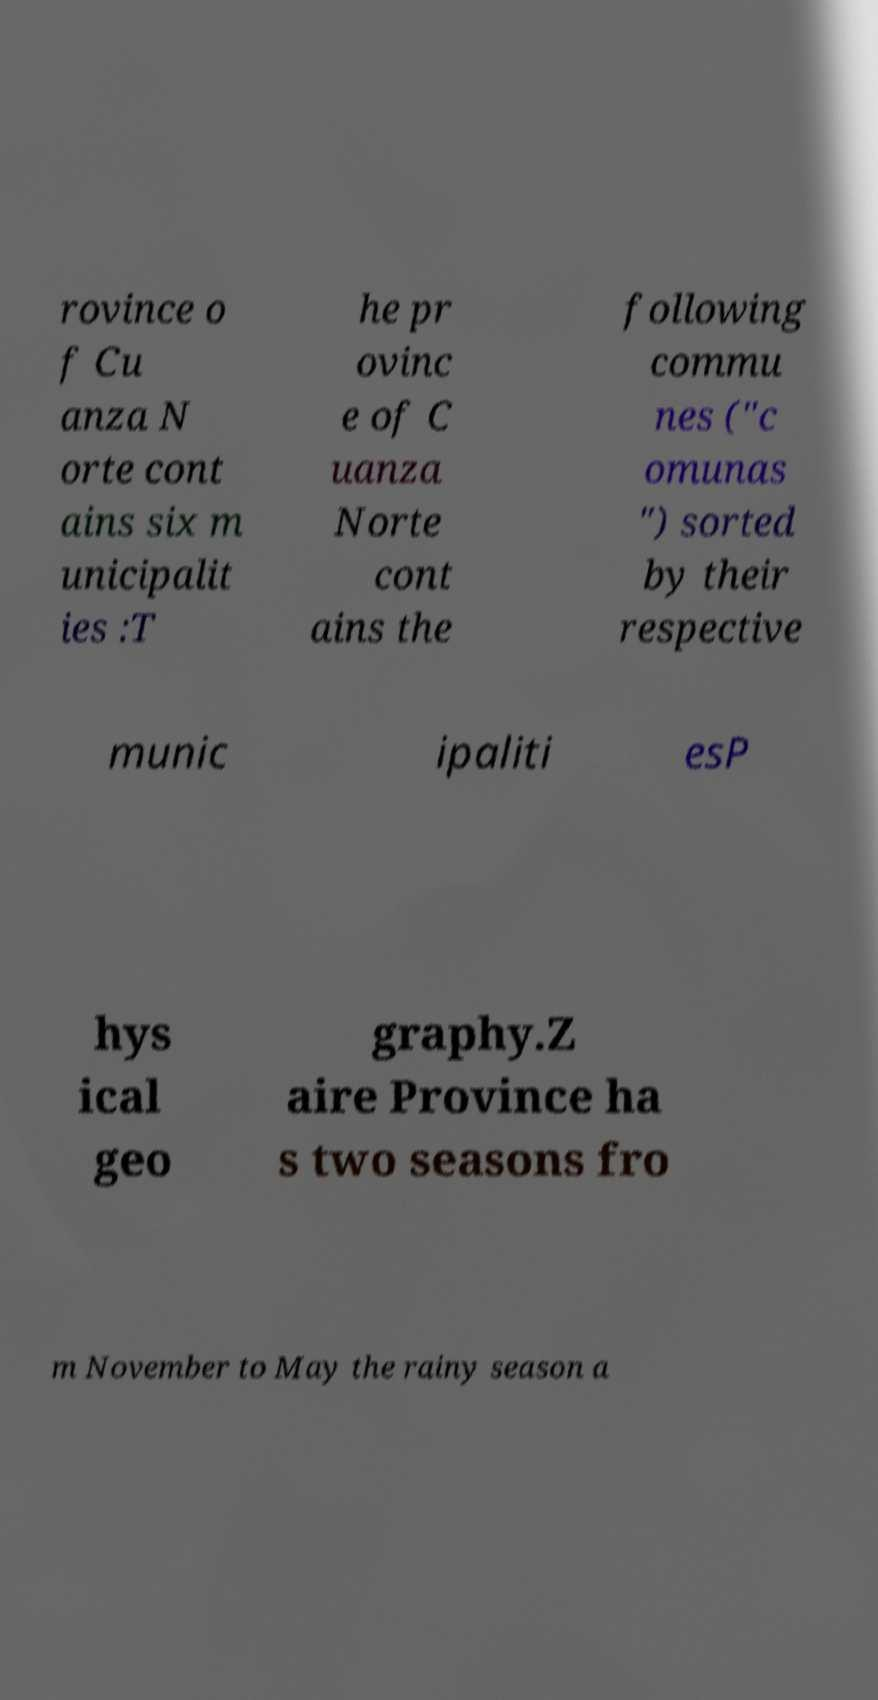For documentation purposes, I need the text within this image transcribed. Could you provide that? rovince o f Cu anza N orte cont ains six m unicipalit ies :T he pr ovinc e of C uanza Norte cont ains the following commu nes ("c omunas ") sorted by their respective munic ipaliti esP hys ical geo graphy.Z aire Province ha s two seasons fro m November to May the rainy season a 